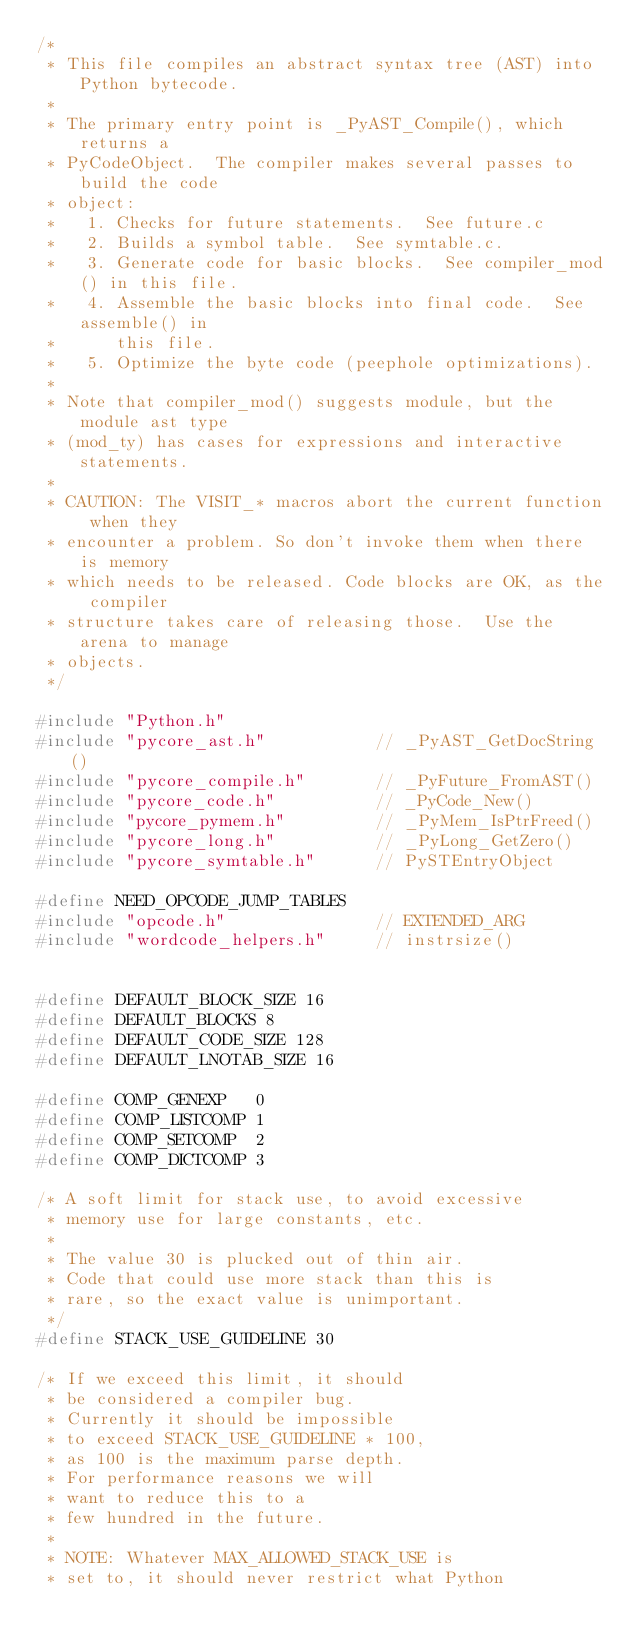Convert code to text. <code><loc_0><loc_0><loc_500><loc_500><_C_>/*
 * This file compiles an abstract syntax tree (AST) into Python bytecode.
 *
 * The primary entry point is _PyAST_Compile(), which returns a
 * PyCodeObject.  The compiler makes several passes to build the code
 * object:
 *   1. Checks for future statements.  See future.c
 *   2. Builds a symbol table.  See symtable.c.
 *   3. Generate code for basic blocks.  See compiler_mod() in this file.
 *   4. Assemble the basic blocks into final code.  See assemble() in
 *      this file.
 *   5. Optimize the byte code (peephole optimizations).
 *
 * Note that compiler_mod() suggests module, but the module ast type
 * (mod_ty) has cases for expressions and interactive statements.
 *
 * CAUTION: The VISIT_* macros abort the current function when they
 * encounter a problem. So don't invoke them when there is memory
 * which needs to be released. Code blocks are OK, as the compiler
 * structure takes care of releasing those.  Use the arena to manage
 * objects.
 */

#include "Python.h"
#include "pycore_ast.h"           // _PyAST_GetDocString()
#include "pycore_compile.h"       // _PyFuture_FromAST()
#include "pycore_code.h"          // _PyCode_New()
#include "pycore_pymem.h"         // _PyMem_IsPtrFreed()
#include "pycore_long.h"          // _PyLong_GetZero()
#include "pycore_symtable.h"      // PySTEntryObject

#define NEED_OPCODE_JUMP_TABLES
#include "opcode.h"               // EXTENDED_ARG
#include "wordcode_helpers.h"     // instrsize()


#define DEFAULT_BLOCK_SIZE 16
#define DEFAULT_BLOCKS 8
#define DEFAULT_CODE_SIZE 128
#define DEFAULT_LNOTAB_SIZE 16

#define COMP_GENEXP   0
#define COMP_LISTCOMP 1
#define COMP_SETCOMP  2
#define COMP_DICTCOMP 3

/* A soft limit for stack use, to avoid excessive
 * memory use for large constants, etc.
 *
 * The value 30 is plucked out of thin air.
 * Code that could use more stack than this is
 * rare, so the exact value is unimportant.
 */
#define STACK_USE_GUIDELINE 30

/* If we exceed this limit, it should
 * be considered a compiler bug.
 * Currently it should be impossible
 * to exceed STACK_USE_GUIDELINE * 100,
 * as 100 is the maximum parse depth.
 * For performance reasons we will
 * want to reduce this to a
 * few hundred in the future.
 *
 * NOTE: Whatever MAX_ALLOWED_STACK_USE is
 * set to, it should never restrict what Python</code> 